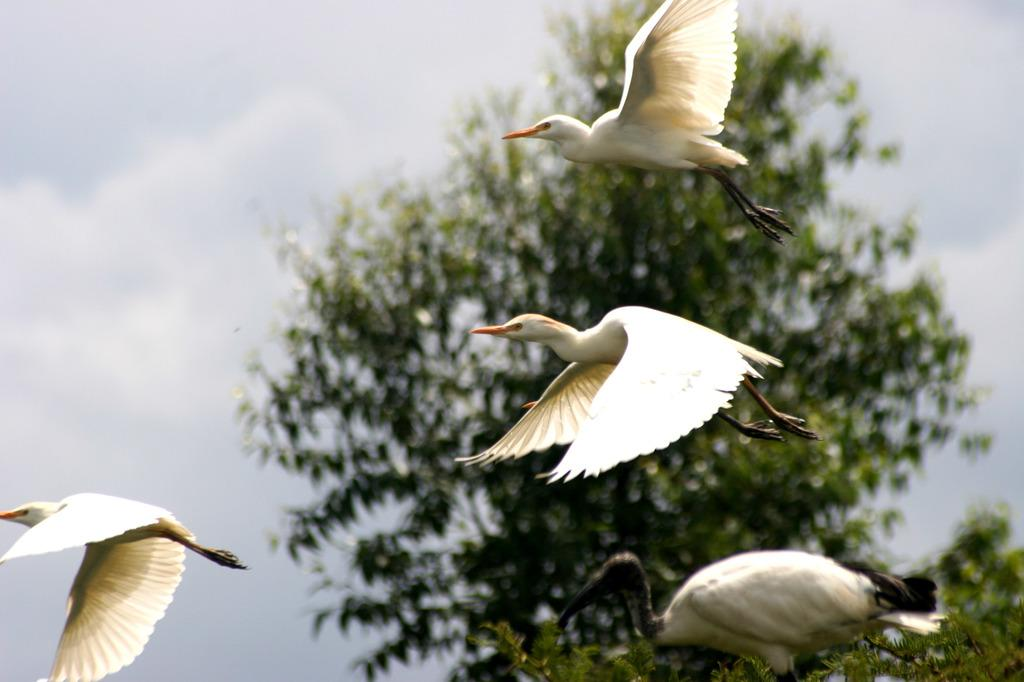What is happening in the sky in the image? There are birds flying in the air in the image. What type of vegetation can be seen in the image? There are trees visible in the image. What else is visible in the sky besides the birds? The sky is visible in the image, and clouds are present. What color is the bird attraction in the image? There is no bird attraction present in the image. How does the bird blow the whistle in the image? There are no birds blowing whistles in the image; the birds are simply flying. 